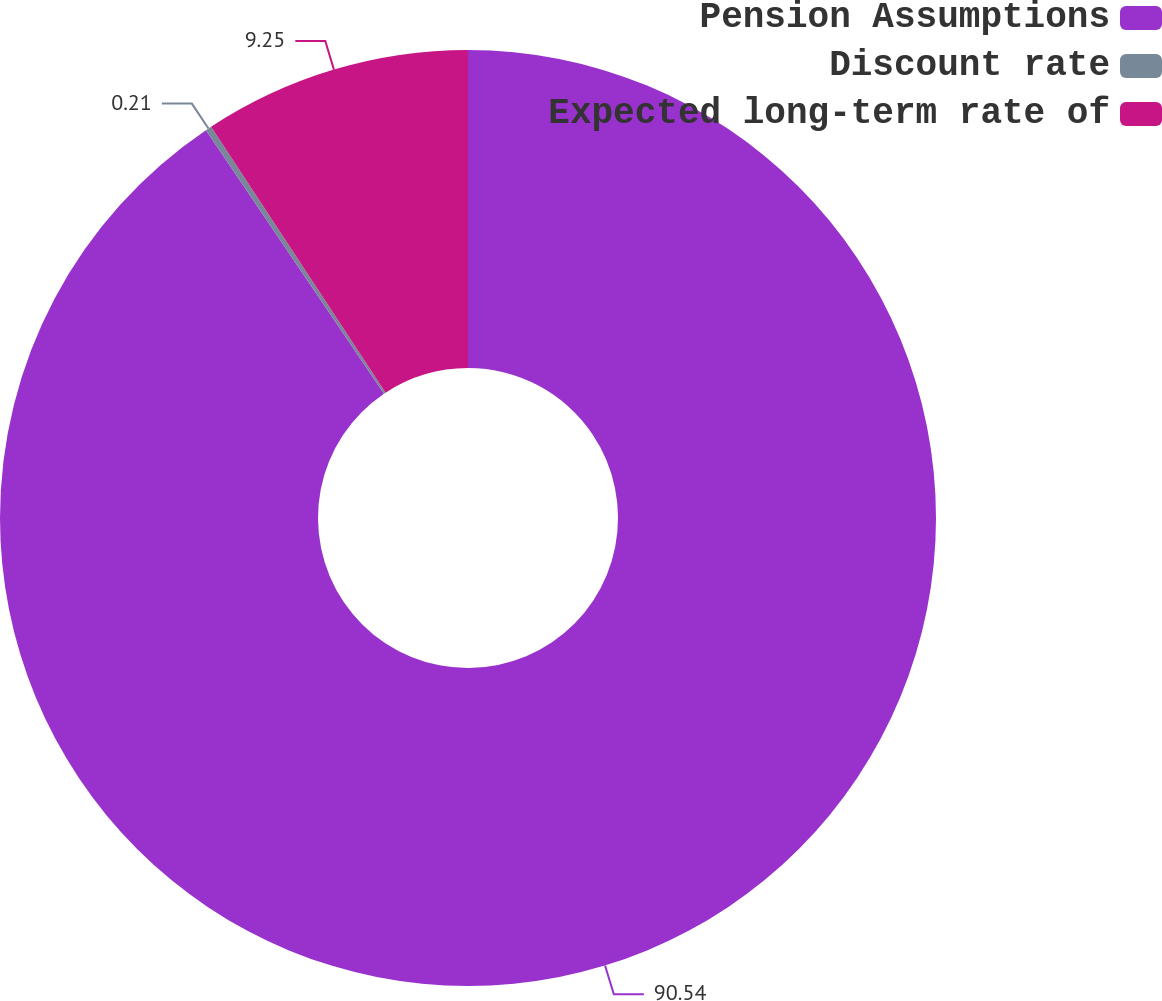Convert chart to OTSL. <chart><loc_0><loc_0><loc_500><loc_500><pie_chart><fcel>Pension Assumptions<fcel>Discount rate<fcel>Expected long-term rate of<nl><fcel>90.54%<fcel>0.21%<fcel>9.25%<nl></chart> 